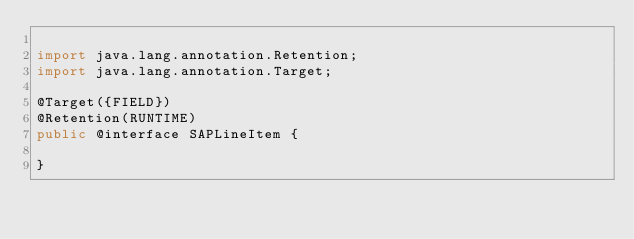<code> <loc_0><loc_0><loc_500><loc_500><_Java_>
import java.lang.annotation.Retention;
import java.lang.annotation.Target;

@Target({FIELD})
@Retention(RUNTIME)
public @interface SAPLineItem {

}
</code> 